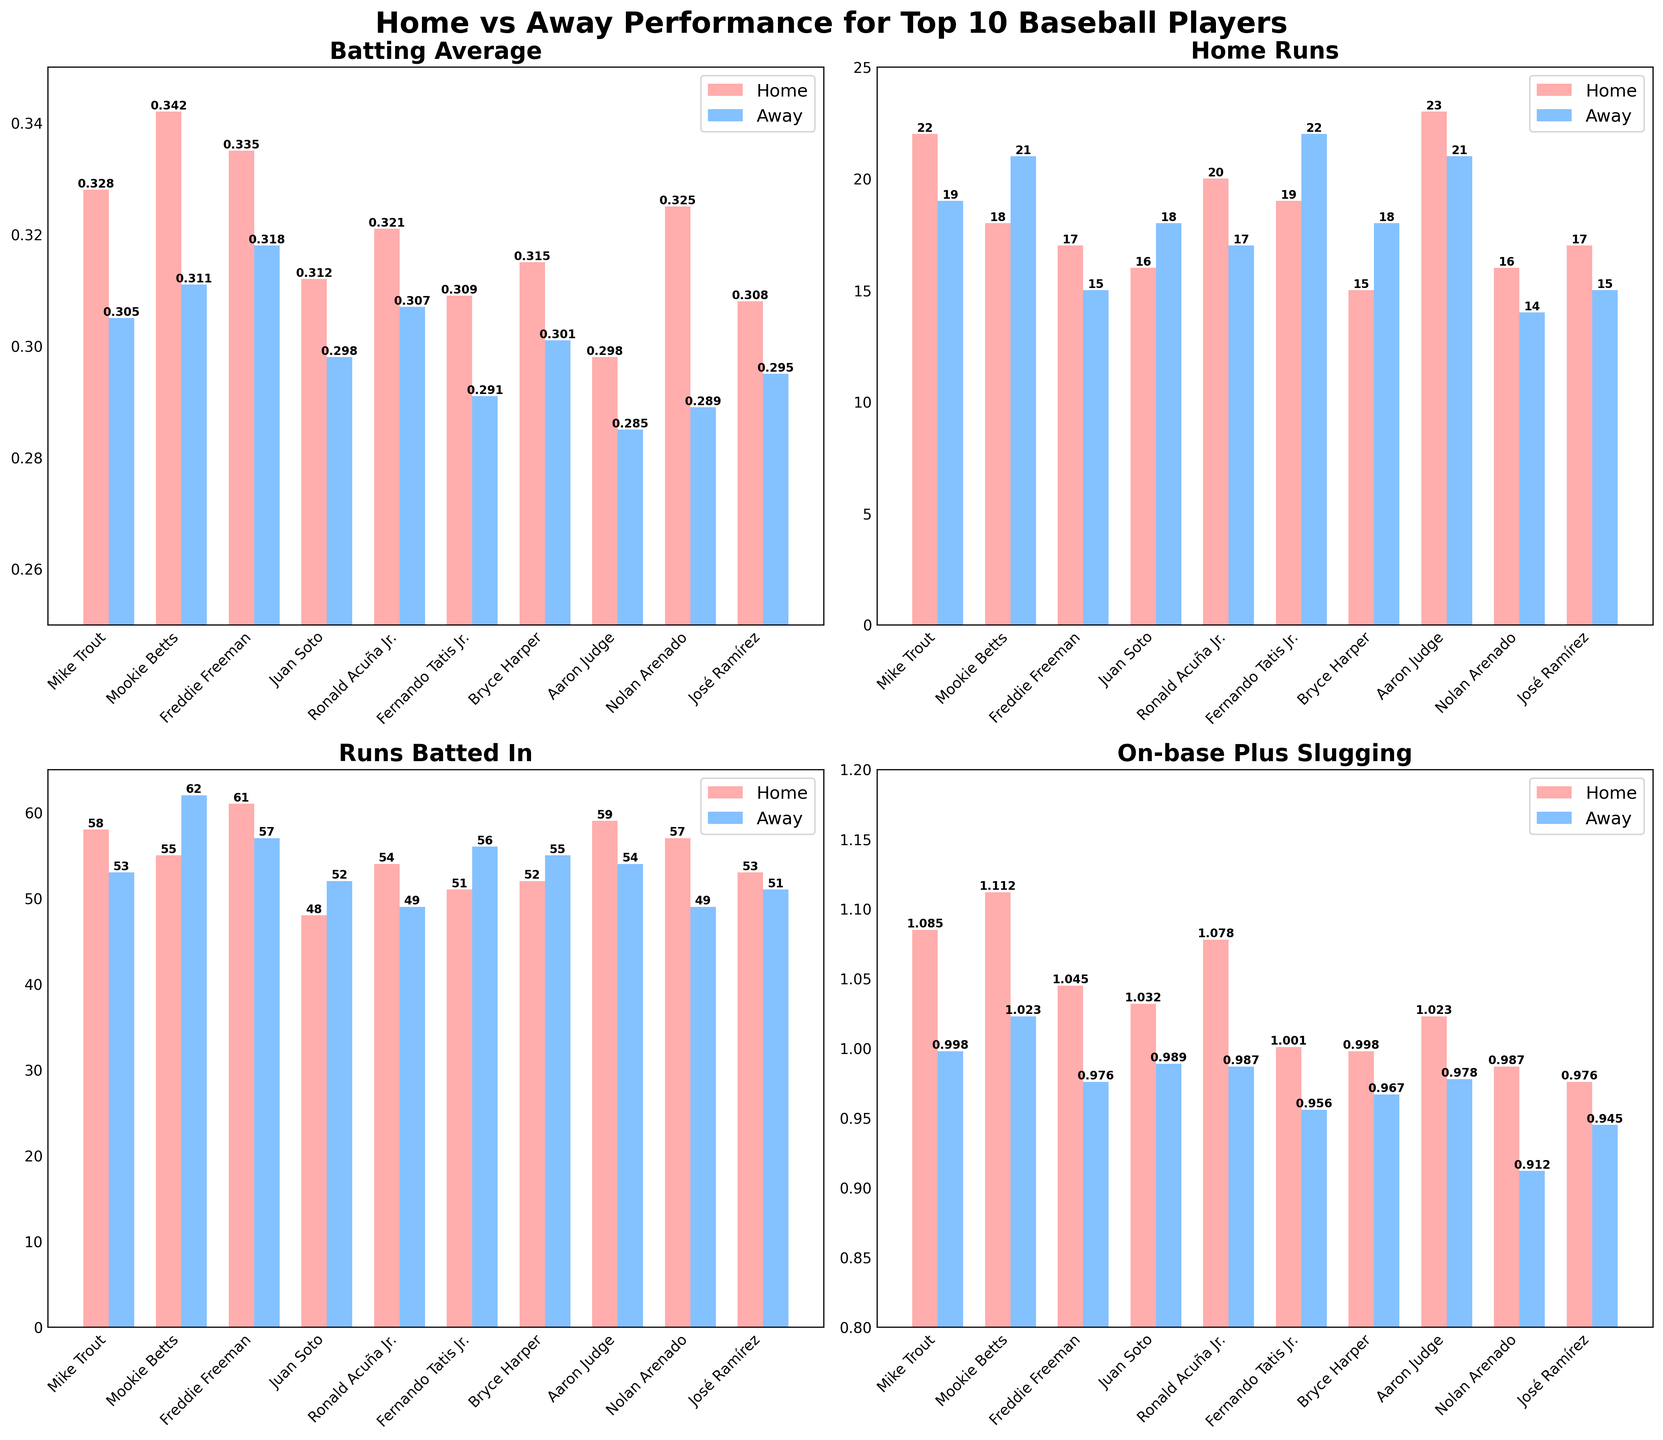What player has the highest home batting average? By visually inspecting the batting average subplot, the player with the tallest red bar, representing home performance, will have the highest home batting average. This is Mookie Betts, with a home average of 0.342.
Answer: Mookie Betts Between Mike Trout and Aaron Judge, who has more home runs away? Look at the height of the blue bars associated with Mike Trout and Aaron Judge in the home run subplot. Mike Trout's blue bar appears slightly shorter than Aaron Judge's blue bar. Mike Trout has 19 away home runs, while Aaron Judge has 21.
Answer: Aaron Judge Which player has the largest difference in RBI between home and away games? We need to compare the height difference of red and blue bars for RBI for each player. Fernando Tatis Jr. shows the largest difference, with 56 away RBIs compared to 51 home RBIs, making a difference of 5.
Answer: Fernando Tatis Jr Which player shows the least difference in batting average between home and away games? We must measure the height difference between red and blue bars for batting averages. Juan Soto has the least difference, with home AVG of 0.312 and away AVG of 0.298, a difference of 0.014.
Answer: Juan Soto How many total home runs were hit at home by the top 10 players? Summing the home run values for all players in the home run subplot gives 22 (Trout) + 18 (Betts) + 17 (Freeman) + 16 (Soto) + 20 (Acuña Jr.) + 19 (Tatis Jr.) + 15 (Harper) + 23 (Judge) + 16 (Arenado) + 17 (Ramírez) = 183.
Answer: 183 Which player has the highest OPS at home? Identify the highest red bar in the OPS subplot, indicating the player with the highest home OPS. Mike Trout has the highest home OPS, which is 1.085.
Answer: Mike Trout What is the combined away OPS for the first five players? Adding the away OPS for Mike Trout (0.998), Mookie Betts (1.023), Freddie Freeman (0.976), Juan Soto (0.989), and Ronald Acuña Jr. (0.987). Sum is 0.998 + 1.023 + 0.976 + 0.989 + 0.987 = 4.973.
Answer: 4.973 Who has more home RBI between Bryce Harper and Fernando Tatis Jr.? Comparing the height of the red bars for home RBI of Bryce Harper and Fernando Tatis Jr., Tatis Jr. has 51 home RBIs while Harper has 52. Bryce Harper has more home RBIs.
Answer: Bryce Harper Which player’s home and away OPS are closest in value? Visually comparing the height difference of red and blue bars in the OPS subplot, the smallest difference is observed for Juan Soto's home OPS of 1.032 and away OPS of 0.989, a difference of 0.043.
Answer: Juan Soto Who has more away home runs, Mookie Betts or Ronald Acuña Jr.? By checking the blue bars in the home run subplot for both players, Mookie Betts has 21 away home runs and Ronald Acuña Jr. has 17. Mookie Betts has more away home runs.
Answer: Mookie Betts 